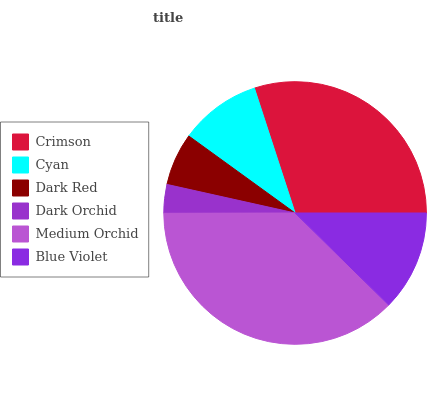Is Dark Orchid the minimum?
Answer yes or no. Yes. Is Medium Orchid the maximum?
Answer yes or no. Yes. Is Cyan the minimum?
Answer yes or no. No. Is Cyan the maximum?
Answer yes or no. No. Is Crimson greater than Cyan?
Answer yes or no. Yes. Is Cyan less than Crimson?
Answer yes or no. Yes. Is Cyan greater than Crimson?
Answer yes or no. No. Is Crimson less than Cyan?
Answer yes or no. No. Is Blue Violet the high median?
Answer yes or no. Yes. Is Cyan the low median?
Answer yes or no. Yes. Is Medium Orchid the high median?
Answer yes or no. No. Is Medium Orchid the low median?
Answer yes or no. No. 